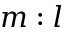<formula> <loc_0><loc_0><loc_500><loc_500>m \colon l</formula> 